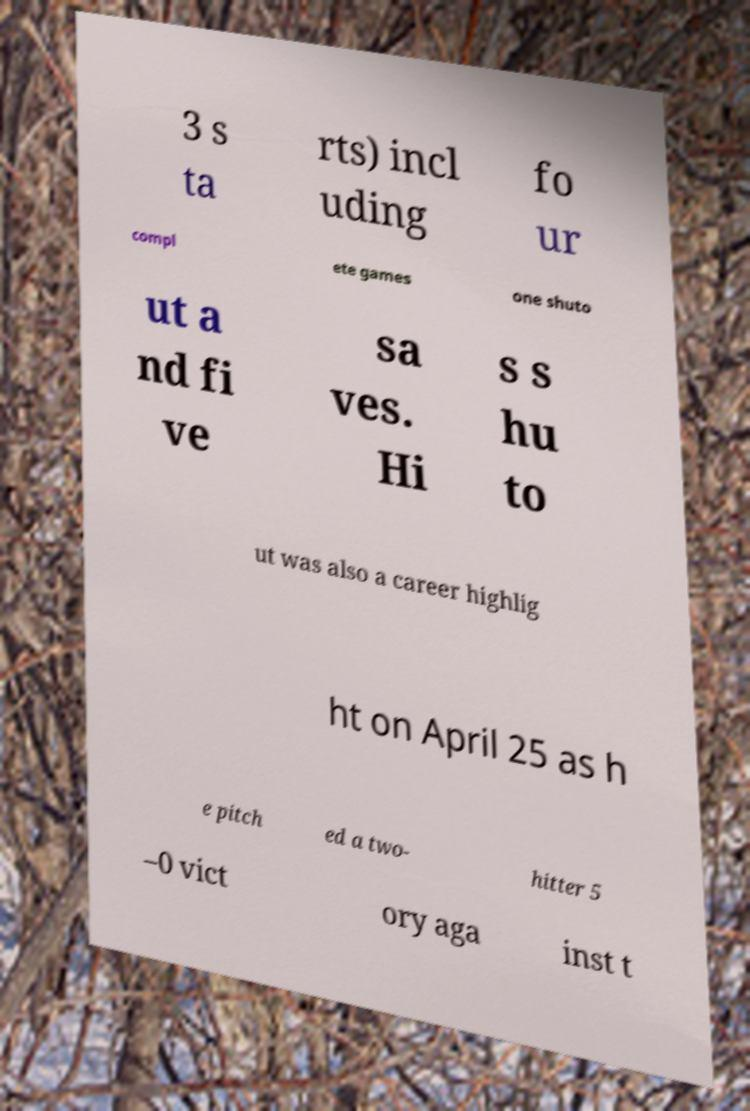For documentation purposes, I need the text within this image transcribed. Could you provide that? 3 s ta rts) incl uding fo ur compl ete games one shuto ut a nd fi ve sa ves. Hi s s hu to ut was also a career highlig ht on April 25 as h e pitch ed a two- hitter 5 –0 vict ory aga inst t 